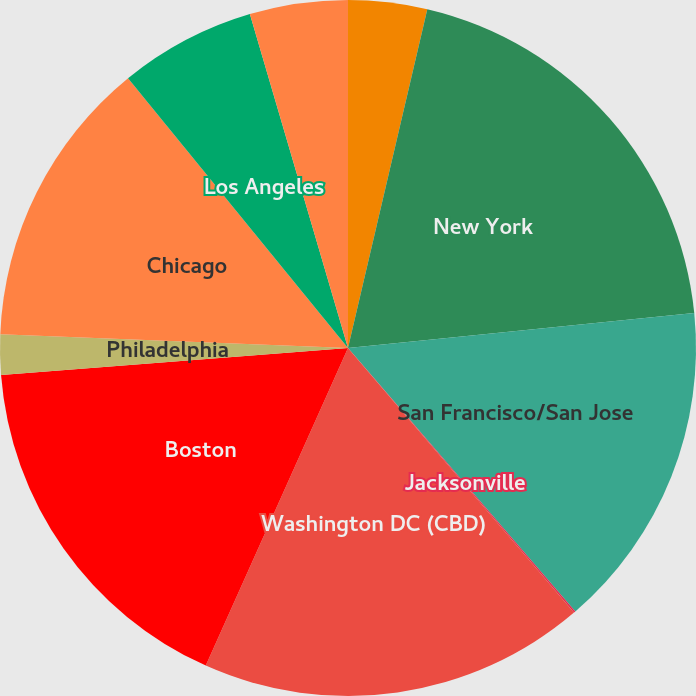Convert chart. <chart><loc_0><loc_0><loc_500><loc_500><pie_chart><fcel>Florida Gulf Coast<fcel>New York<fcel>San Francisco/San Jose<fcel>Jacksonville<fcel>Washington DC (CBD)<fcel>Boston<fcel>Philadelphia<fcel>Chicago<fcel>Los Angeles<fcel>Seattle<nl><fcel>3.66%<fcel>19.74%<fcel>15.27%<fcel>0.08%<fcel>17.95%<fcel>17.06%<fcel>1.87%<fcel>13.48%<fcel>6.34%<fcel>4.55%<nl></chart> 